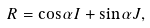Convert formula to latex. <formula><loc_0><loc_0><loc_500><loc_500>R = \cos \alpha I + \sin \alpha { J } ,</formula> 